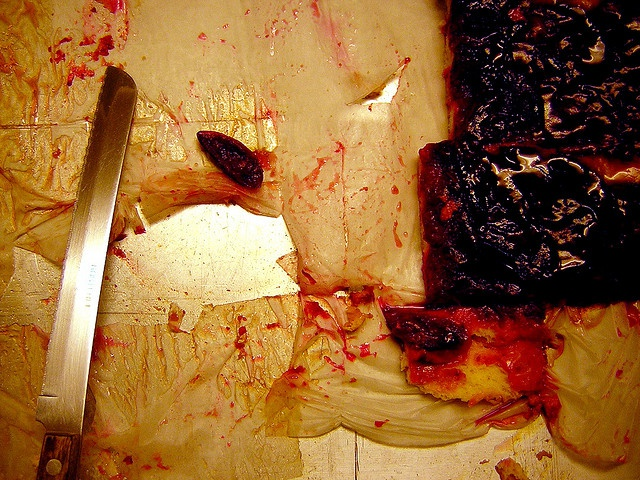Describe the objects in this image and their specific colors. I can see cake in maroon, black, and brown tones, cake in maroon, tan, red, and orange tones, and knife in maroon, ivory, olive, and tan tones in this image. 